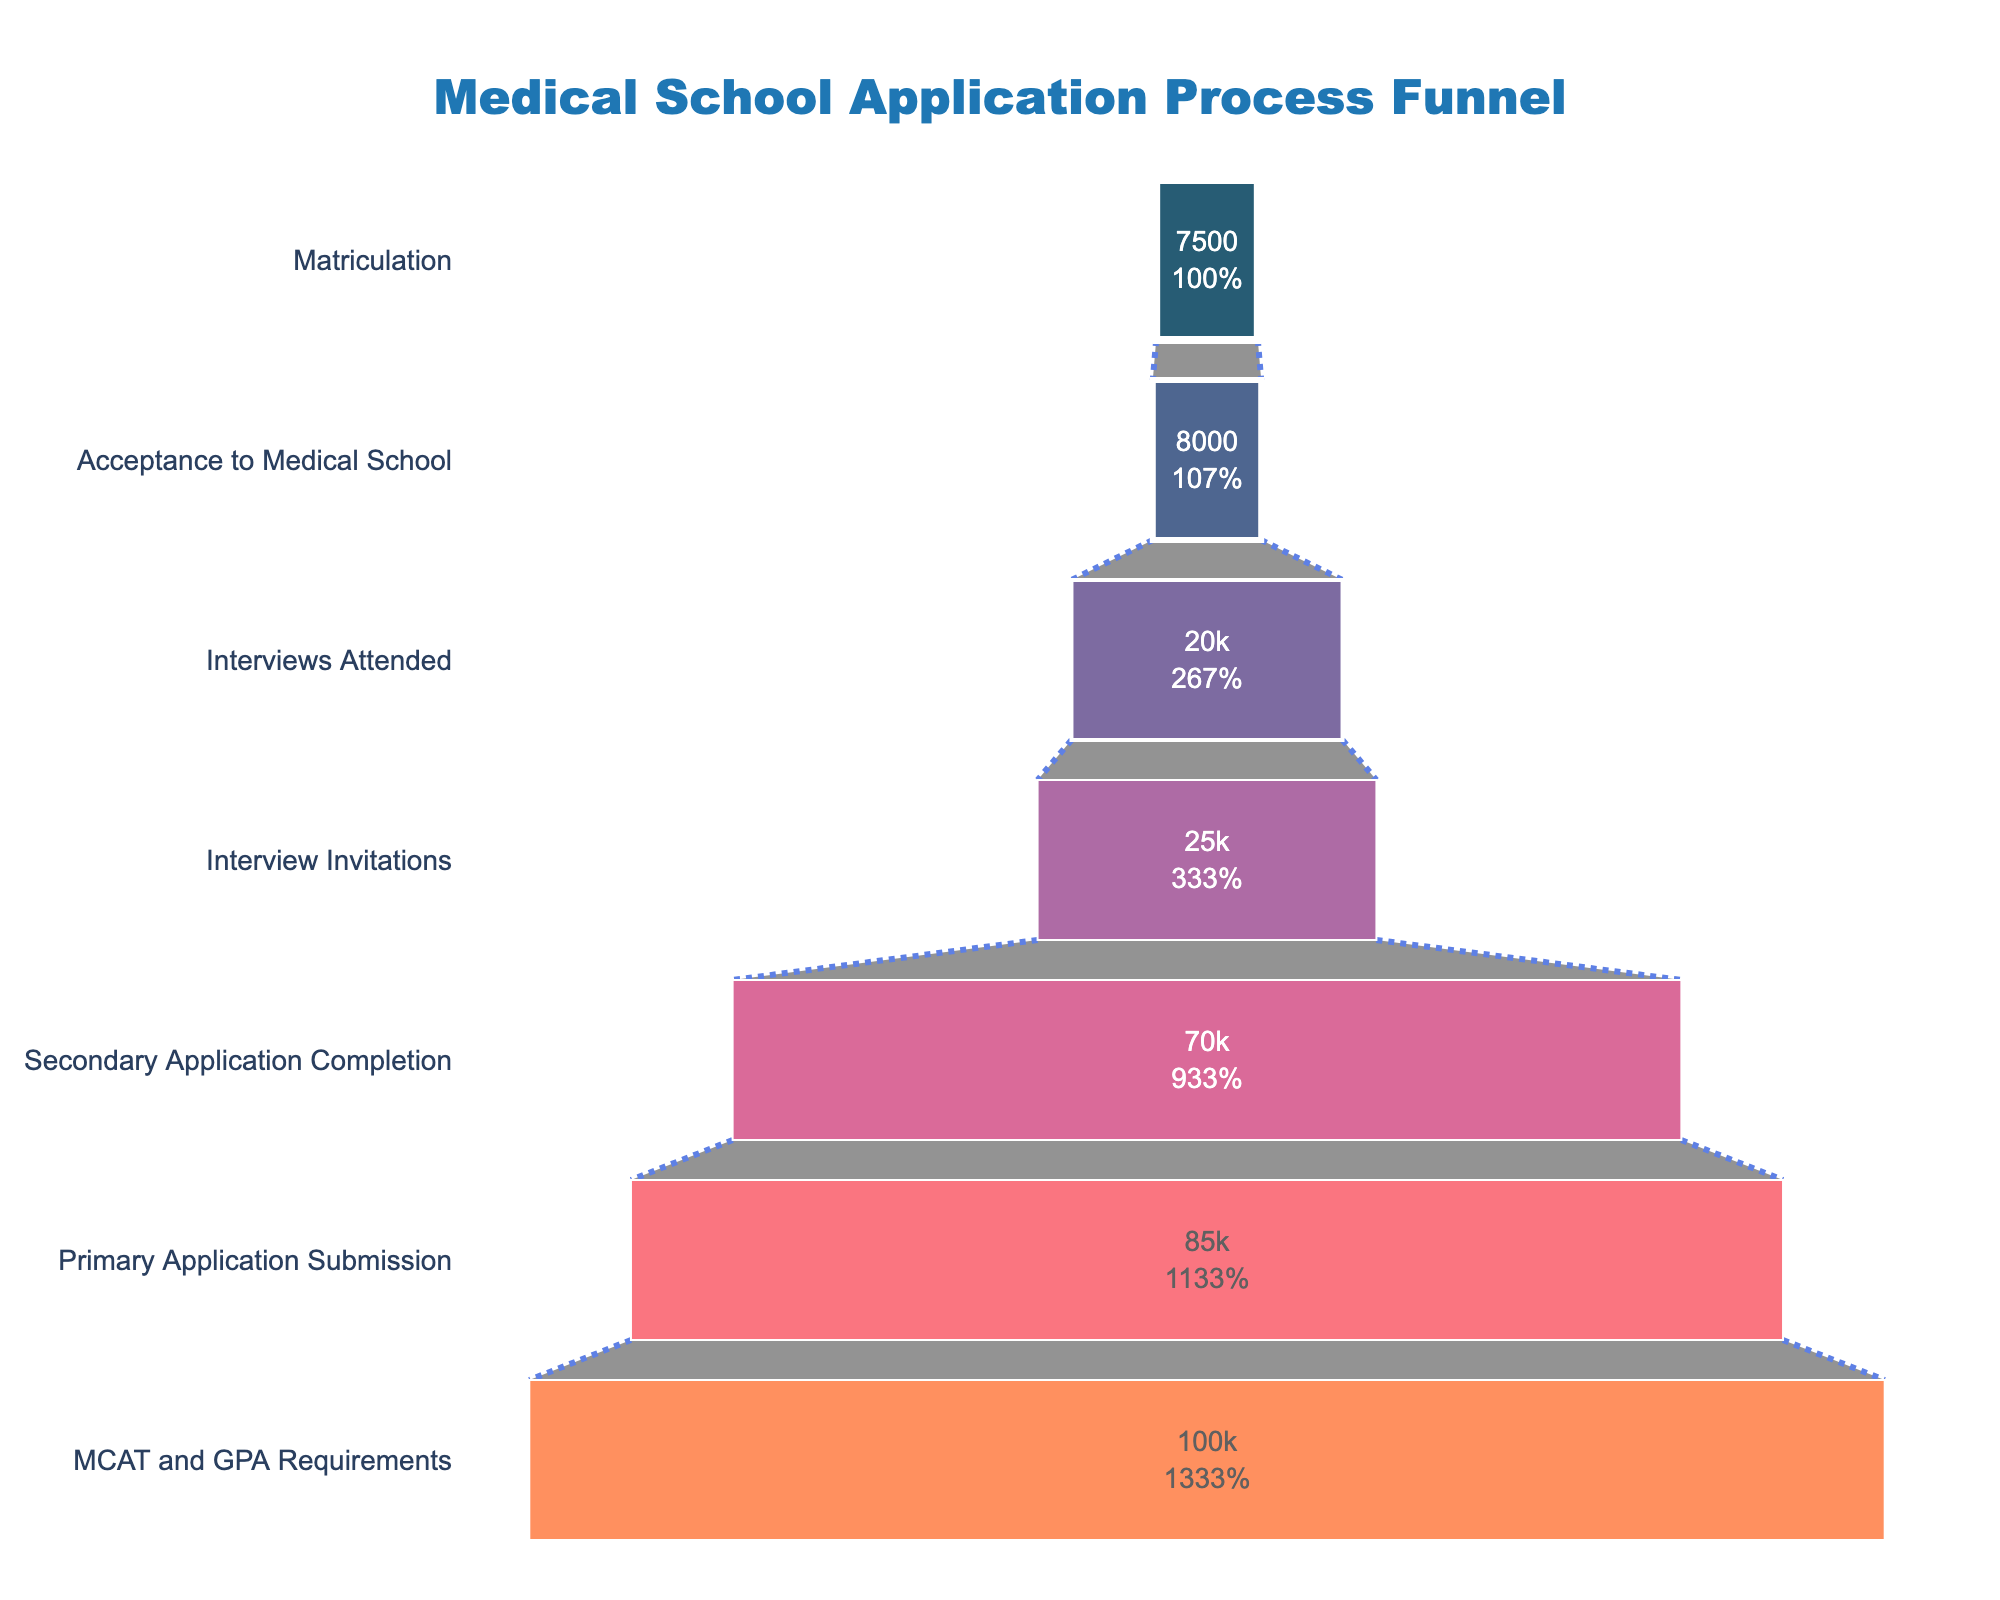What is the title of the funnel chart? The title of the funnel chart is located at the top center of the figure and typically describes the main focus or topic of the chart.
Answer: Medical School Application Process Funnel Which stage has the highest number of applicants? To determine the stage with the highest number of applicants, look at the topmost funnel level, which represents the initial stage of the process.
Answer: MCAT and GPA Requirements What is the success rate from Interview Invitations to Acceptances? The success rate can be calculated by dividing the number of Acceptances by the number of Interview Invitations. Here, 8,000 (Acceptances) divided by 25,000 (Interview Invitations) gives the success rate.
Answer: 32% How many applicants did not complete the secondary application? Subtract the number of Secondary Application Completers from the Primary Application Submitters. That's 85,000 (Primary Application) minus 70,000 (Secondary Application).
Answer: 15,000 What is the overall success rate from MCAT and GPA Requirements to Matriculation? The overall success rate is found by dividing the number of Matriculations by the number of initial applicants who met MCAT and GPA Requirements. So, 7,500 (Matriculations) divided by 100,000 (Initial Applicants).
Answer: 7.5% By how much does the number of applicants decrease from Primary Application Submission to Interview Invitations? Subtract the number of Interview Invitations from the number of Primary Application Submissions. So, 85,000 (Primary Application) minus 25,000 (Interview Invitations).
Answer: 60,000 Which stage shows the greatest percentage drop compared to its previous stage? Compare the percentage drop between consecutive stages by dividing the difference by the previous stage's number, and identify the greatest drop.
Answer: Interview Invitations to Interviews Attended How many applicants attended the interviews but were not accepted? Subtract the number of Acceptances from the number of Interviews Attended. So, 20,000 (Interviews Attended) minus 8,000 (Acceptances).
Answer: 12,000 Which color is used to represent the Acceptance to Medical School stage? Identify the color used in the funnel chart for the "Acceptance to Medical School" stage by referring to the visual representation.
Answer: #f95d6a What percentage of the initial applicants submit their primary application? Calculate the percentage by dividing the number of Primary Application Submissions by the total applicants fulfilling MCAT and GPA Requirements, then multiply by 100. So (85,000 / 100,000) * 100.
Answer: 85% 